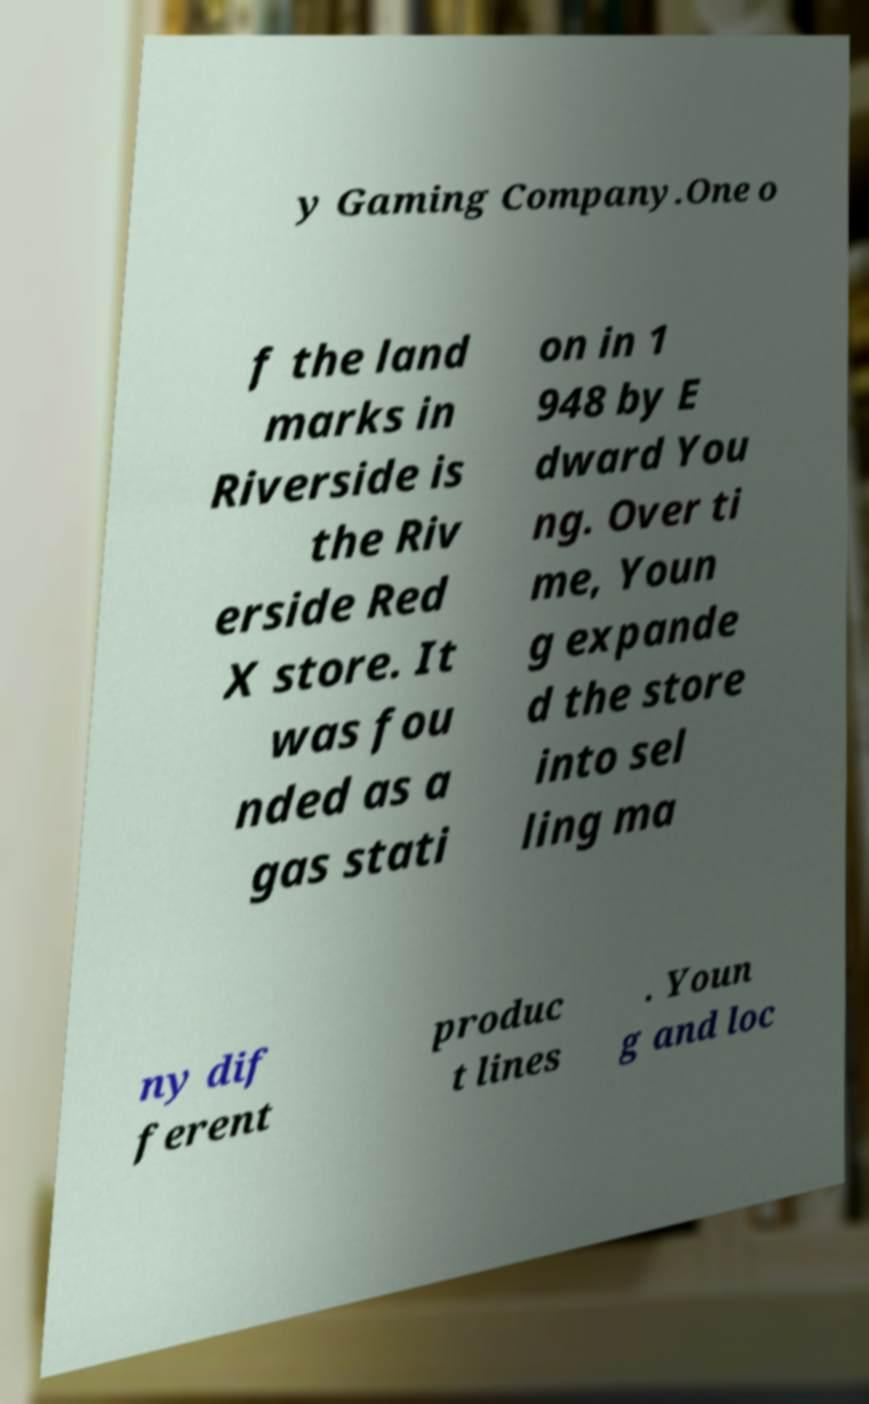Can you read and provide the text displayed in the image?This photo seems to have some interesting text. Can you extract and type it out for me? y Gaming Company.One o f the land marks in Riverside is the Riv erside Red X store. It was fou nded as a gas stati on in 1 948 by E dward You ng. Over ti me, Youn g expande d the store into sel ling ma ny dif ferent produc t lines . Youn g and loc 